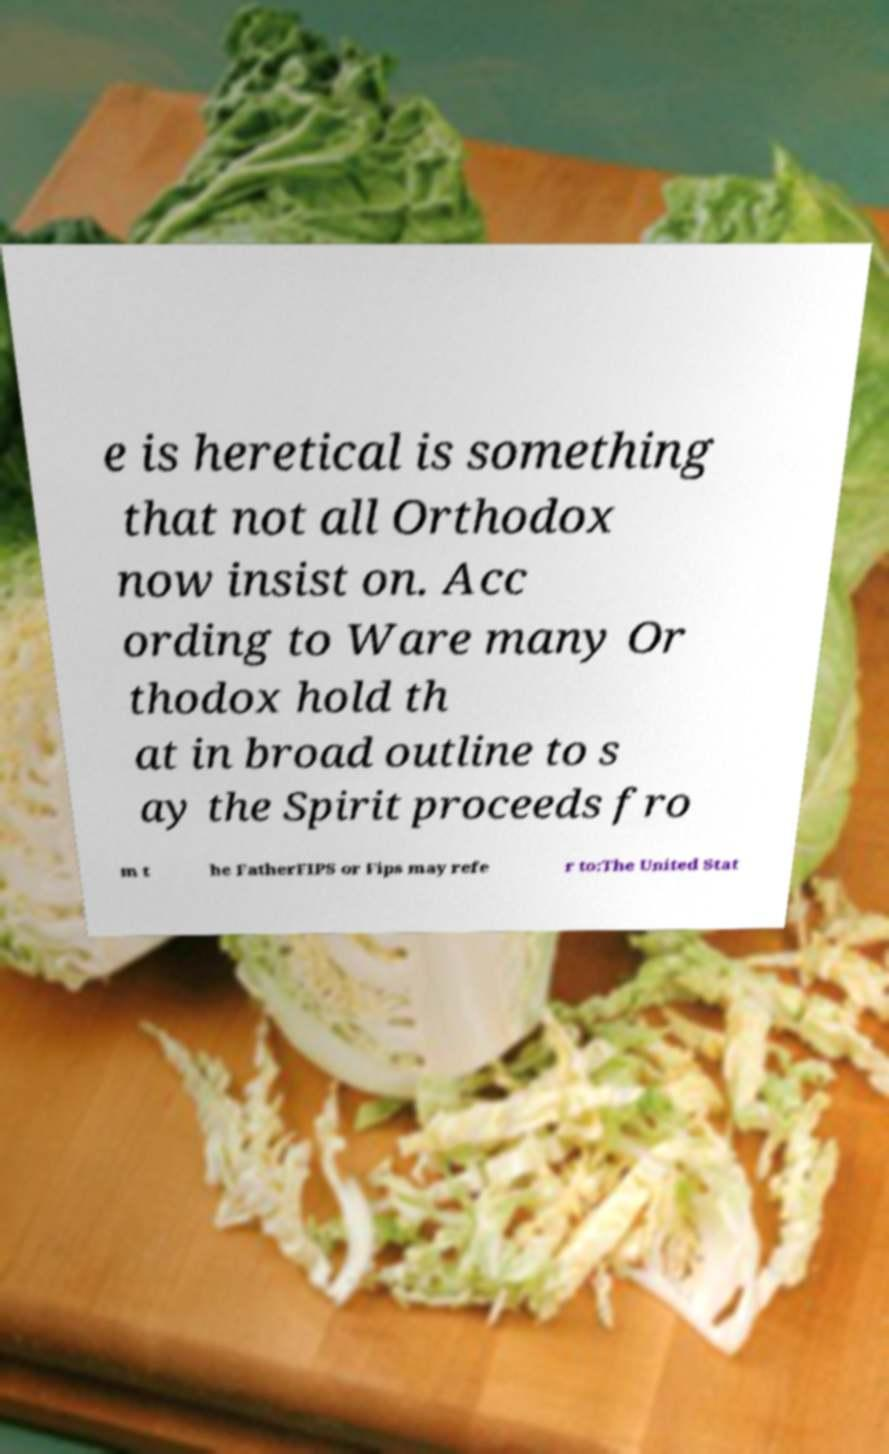What messages or text are displayed in this image? I need them in a readable, typed format. e is heretical is something that not all Orthodox now insist on. Acc ording to Ware many Or thodox hold th at in broad outline to s ay the Spirit proceeds fro m t he FatherFIPS or Fips may refe r to:The United Stat 